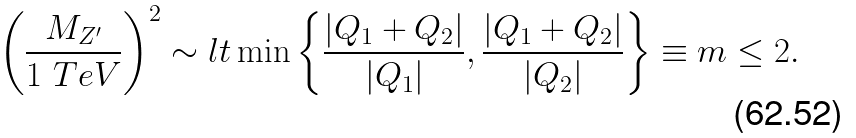Convert formula to latex. <formula><loc_0><loc_0><loc_500><loc_500>\left ( \frac { M _ { Z ^ { \prime } } } { 1 \ T e V } \right ) ^ { 2 } \sim l t \min \left \{ \frac { | Q _ { 1 } + Q _ { 2 } | } { | Q _ { 1 } | } , \frac { | Q _ { 1 } + Q _ { 2 } | } { | Q _ { 2 } | } \right \} \equiv m \leq 2 .</formula> 